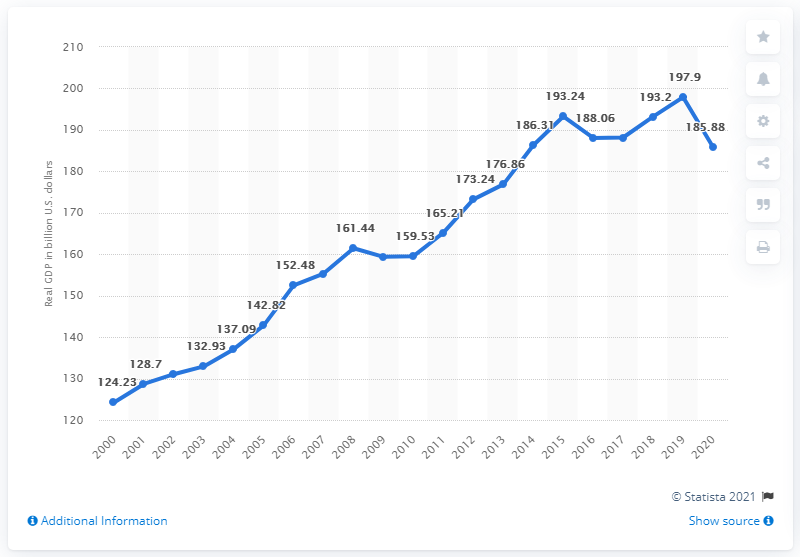Indicate a few pertinent items in this graphic. In 2018, the real GDP of Oklahoma in dollars was 197.9. In 2020, the Gross Domestic Product of Oklahoma was 185.88. 